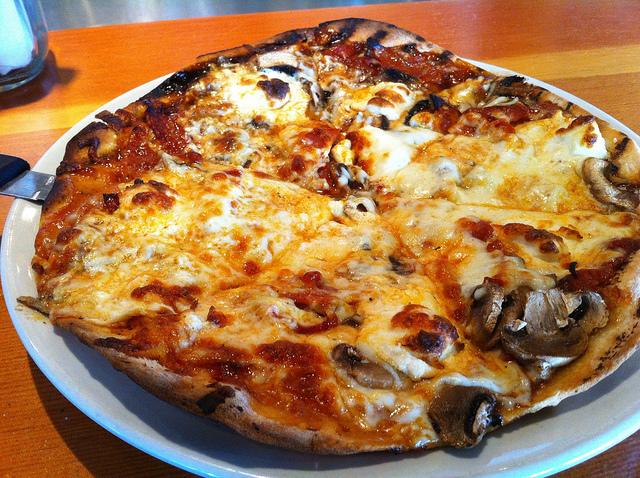Is there cheese in this dish?
Quick response, please. Yes. Could this meal feed more than one person?
Short answer required. Yes. Who made this pizza?
Be succinct. Cook. 